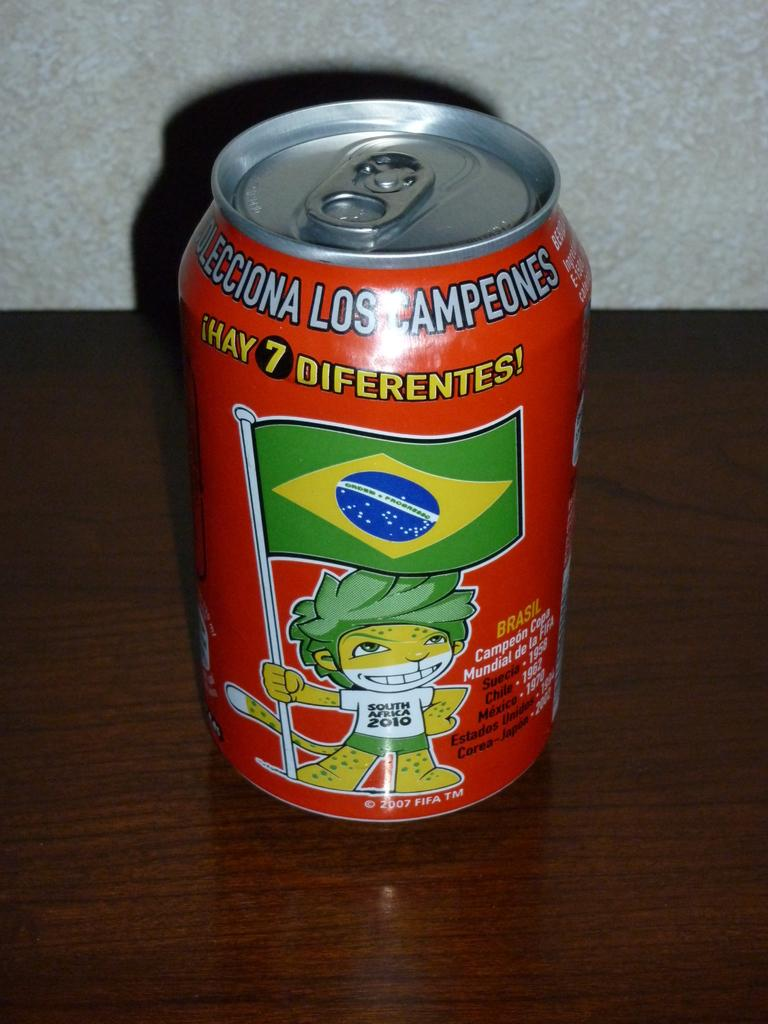<image>
Share a concise interpretation of the image provided. A can with a mascot from South Africa 2010 FIFA is on a brown table. 